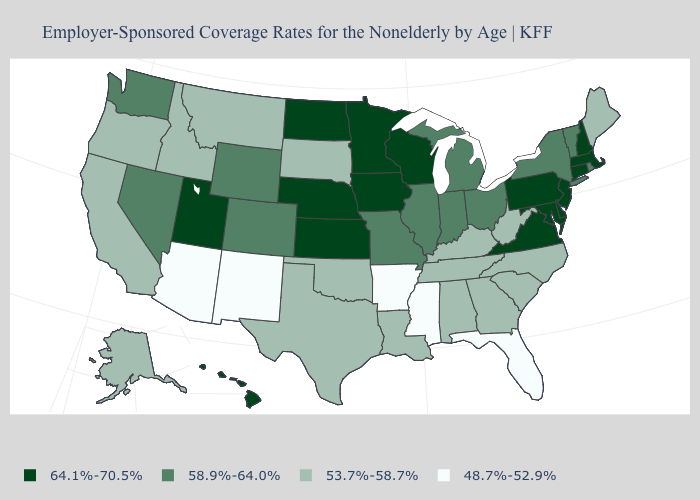Which states have the lowest value in the USA?
Keep it brief. Arizona, Arkansas, Florida, Mississippi, New Mexico. What is the highest value in the USA?
Concise answer only. 64.1%-70.5%. What is the value of Hawaii?
Write a very short answer. 64.1%-70.5%. Does the map have missing data?
Concise answer only. No. What is the lowest value in states that border Pennsylvania?
Short answer required. 53.7%-58.7%. Name the states that have a value in the range 48.7%-52.9%?
Keep it brief. Arizona, Arkansas, Florida, Mississippi, New Mexico. Does Florida have the lowest value in the USA?
Be succinct. Yes. What is the value of Minnesota?
Concise answer only. 64.1%-70.5%. Name the states that have a value in the range 53.7%-58.7%?
Keep it brief. Alabama, Alaska, California, Georgia, Idaho, Kentucky, Louisiana, Maine, Montana, North Carolina, Oklahoma, Oregon, South Carolina, South Dakota, Tennessee, Texas, West Virginia. What is the value of South Carolina?
Quick response, please. 53.7%-58.7%. Is the legend a continuous bar?
Keep it brief. No. What is the value of South Carolina?
Give a very brief answer. 53.7%-58.7%. Which states have the highest value in the USA?
Write a very short answer. Connecticut, Delaware, Hawaii, Iowa, Kansas, Maryland, Massachusetts, Minnesota, Nebraska, New Hampshire, New Jersey, North Dakota, Pennsylvania, Utah, Virginia, Wisconsin. Does Virginia have the lowest value in the USA?
Concise answer only. No. 